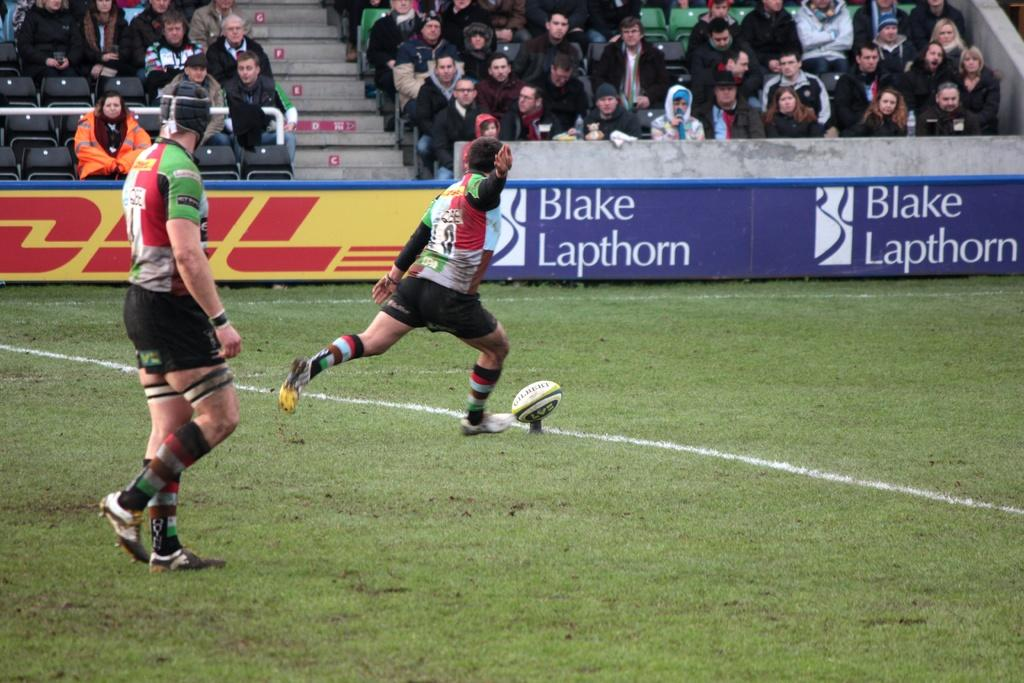<image>
Offer a succinct explanation of the picture presented. A rugby player about to kick a ball with DHL and Blake Lapthorn advertisements on the side lines. 